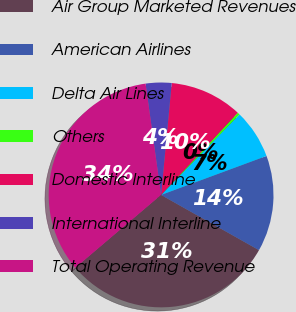<chart> <loc_0><loc_0><loc_500><loc_500><pie_chart><fcel>Air Group Marketed Revenues<fcel>American Airlines<fcel>Delta Air Lines<fcel>Others<fcel>Domestic Interline<fcel>International Interline<fcel>Total Operating Revenue<nl><fcel>30.61%<fcel>13.81%<fcel>7.07%<fcel>0.34%<fcel>10.44%<fcel>3.71%<fcel>34.01%<nl></chart> 